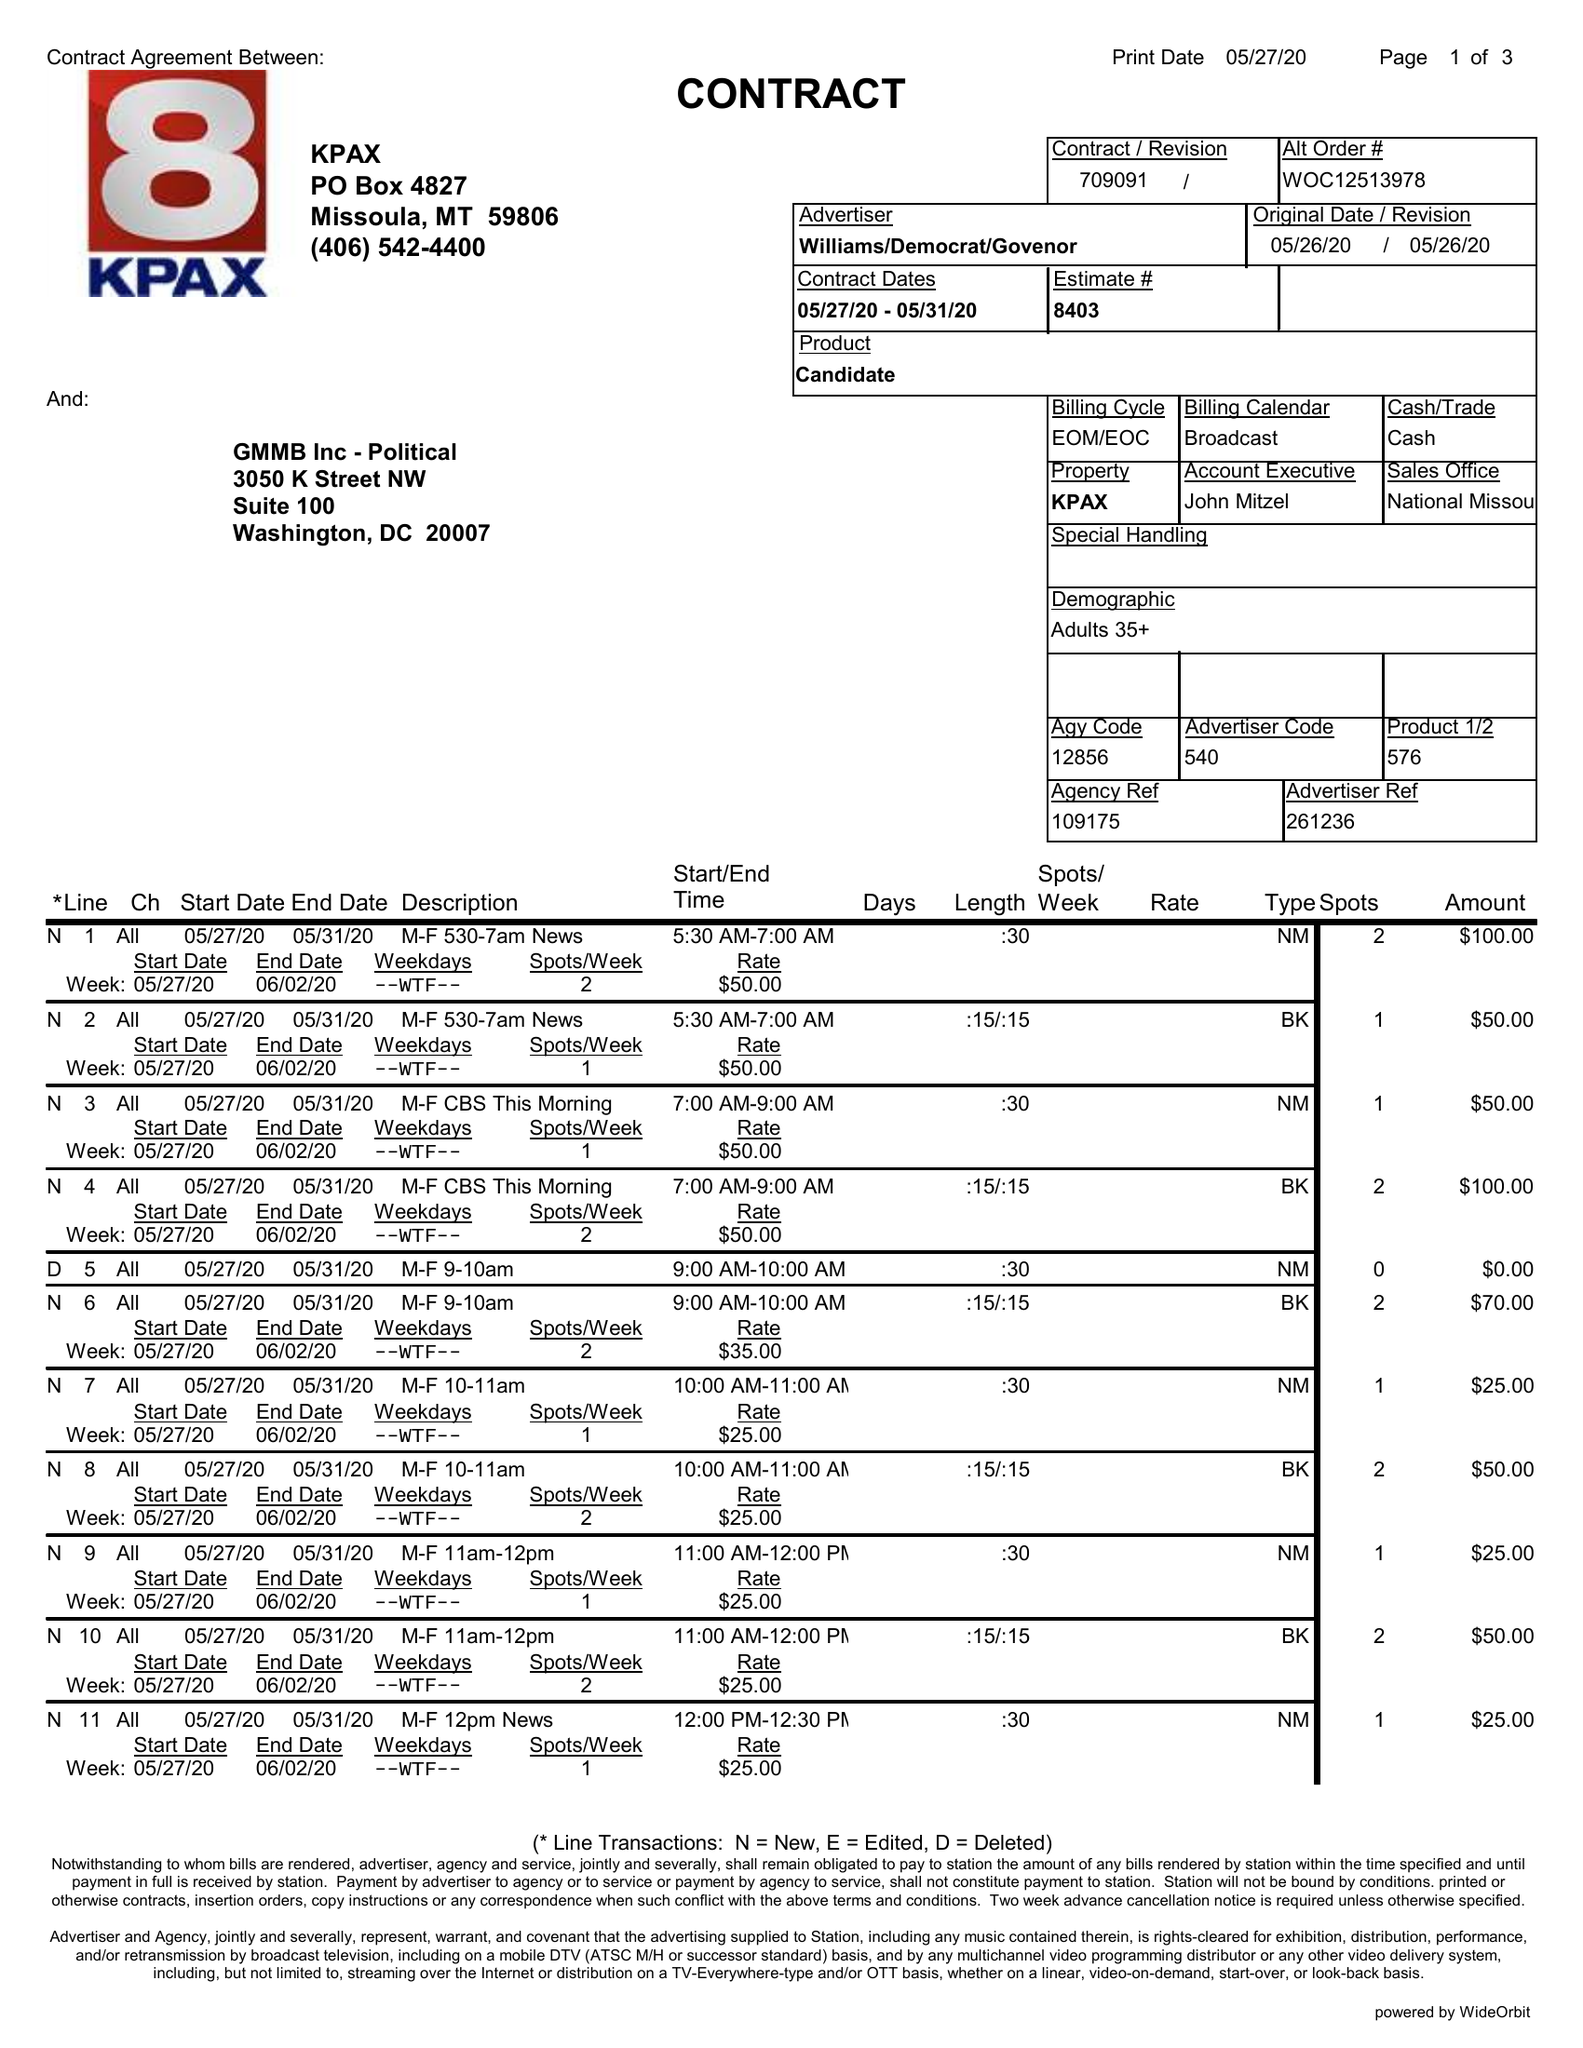What is the value for the flight_to?
Answer the question using a single word or phrase. 05/31/20 